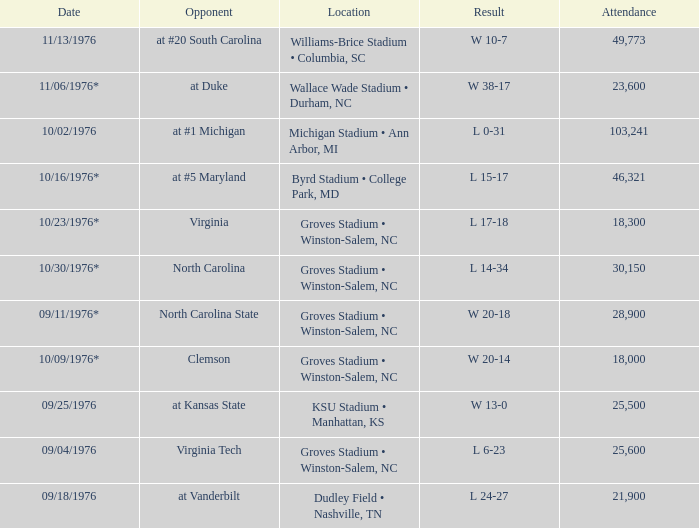What was the date of the game against North Carolina? 10/30/1976*. Give me the full table as a dictionary. {'header': ['Date', 'Opponent', 'Location', 'Result', 'Attendance'], 'rows': [['11/13/1976', 'at #20 South Carolina', 'Williams-Brice Stadium • Columbia, SC', 'W 10-7', '49,773'], ['11/06/1976*', 'at Duke', 'Wallace Wade Stadium • Durham, NC', 'W 38-17', '23,600'], ['10/02/1976', 'at #1 Michigan', 'Michigan Stadium • Ann Arbor, MI', 'L 0-31', '103,241'], ['10/16/1976*', 'at #5 Maryland', 'Byrd Stadium • College Park, MD', 'L 15-17', '46,321'], ['10/23/1976*', 'Virginia', 'Groves Stadium • Winston-Salem, NC', 'L 17-18', '18,300'], ['10/30/1976*', 'North Carolina', 'Groves Stadium • Winston-Salem, NC', 'L 14-34', '30,150'], ['09/11/1976*', 'North Carolina State', 'Groves Stadium • Winston-Salem, NC', 'W 20-18', '28,900'], ['10/09/1976*', 'Clemson', 'Groves Stadium • Winston-Salem, NC', 'W 20-14', '18,000'], ['09/25/1976', 'at Kansas State', 'KSU Stadium • Manhattan, KS', 'W 13-0', '25,500'], ['09/04/1976', 'Virginia Tech', 'Groves Stadium • Winston-Salem, NC', 'L 6-23', '25,600'], ['09/18/1976', 'at Vanderbilt', 'Dudley Field • Nashville, TN', 'L 24-27', '21,900']]} 